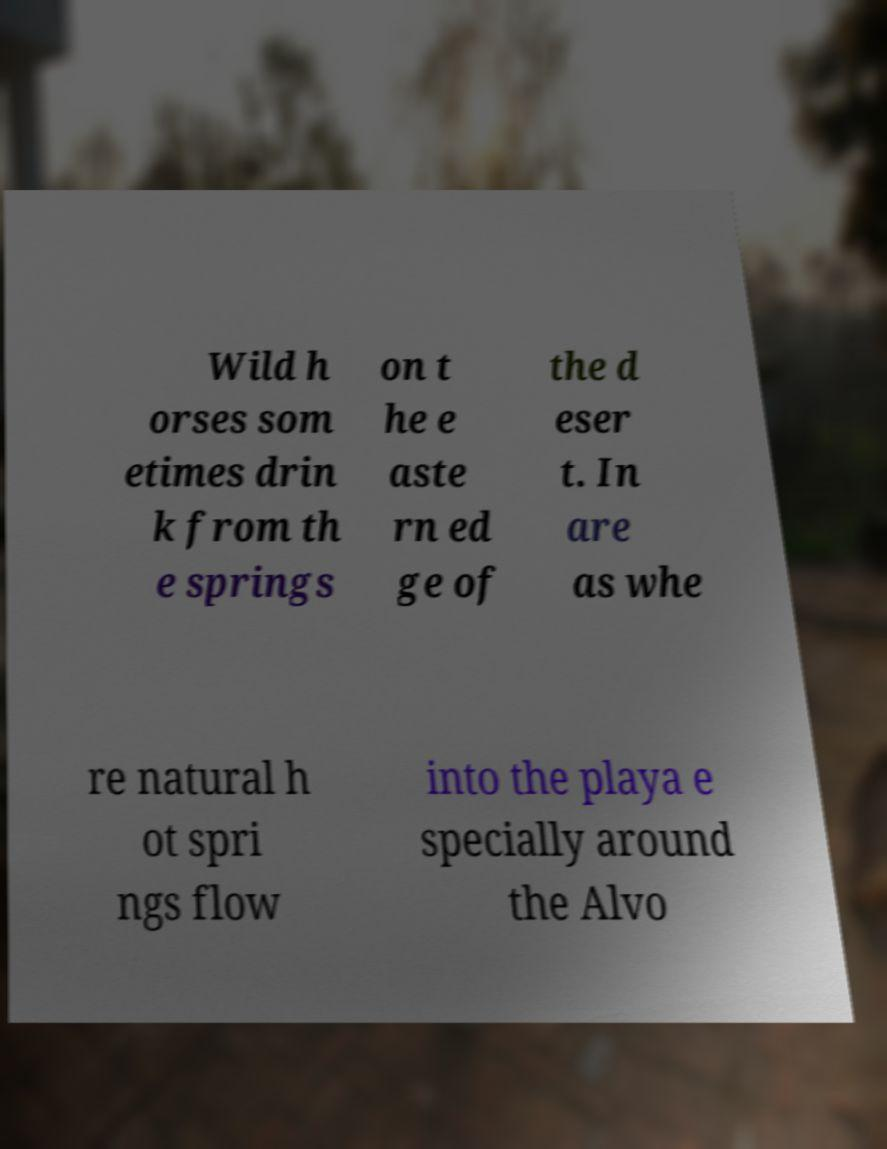Please read and relay the text visible in this image. What does it say? Wild h orses som etimes drin k from th e springs on t he e aste rn ed ge of the d eser t. In are as whe re natural h ot spri ngs flow into the playa e specially around the Alvo 